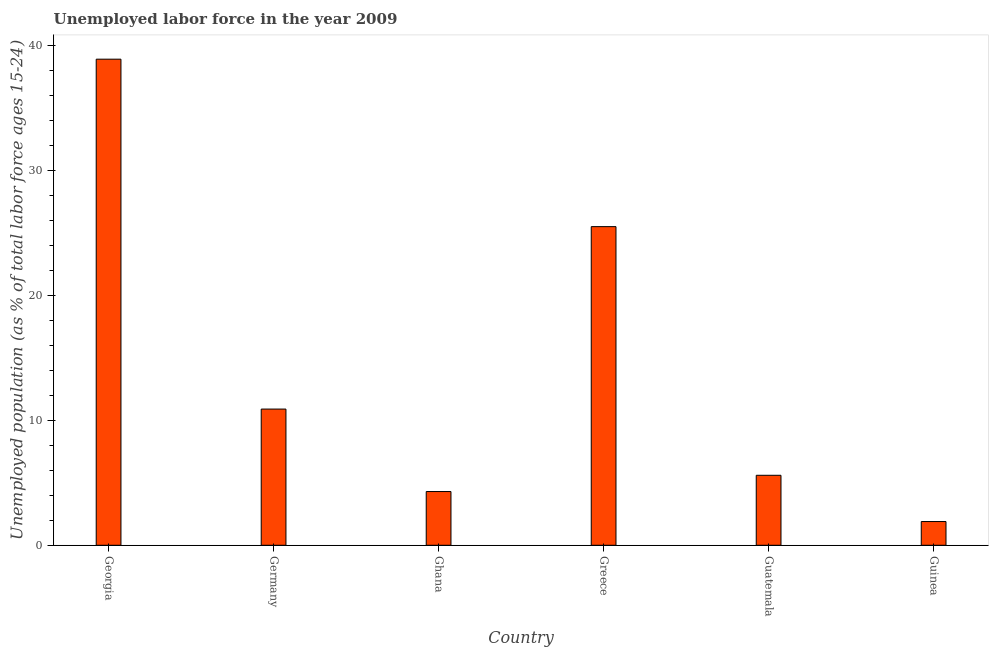Does the graph contain any zero values?
Keep it short and to the point. No. Does the graph contain grids?
Provide a succinct answer. No. What is the title of the graph?
Offer a terse response. Unemployed labor force in the year 2009. What is the label or title of the X-axis?
Offer a very short reply. Country. What is the label or title of the Y-axis?
Offer a terse response. Unemployed population (as % of total labor force ages 15-24). What is the total unemployed youth population in Guinea?
Your answer should be compact. 1.9. Across all countries, what is the maximum total unemployed youth population?
Offer a terse response. 38.9. Across all countries, what is the minimum total unemployed youth population?
Offer a very short reply. 1.9. In which country was the total unemployed youth population maximum?
Keep it short and to the point. Georgia. In which country was the total unemployed youth population minimum?
Make the answer very short. Guinea. What is the sum of the total unemployed youth population?
Make the answer very short. 87.1. What is the average total unemployed youth population per country?
Give a very brief answer. 14.52. What is the median total unemployed youth population?
Provide a short and direct response. 8.25. What is the ratio of the total unemployed youth population in Guatemala to that in Guinea?
Keep it short and to the point. 2.95. Is the total unemployed youth population in Greece less than that in Guinea?
Provide a succinct answer. No. What is the difference between the highest and the second highest total unemployed youth population?
Give a very brief answer. 13.4. Is the sum of the total unemployed youth population in Georgia and Guinea greater than the maximum total unemployed youth population across all countries?
Your answer should be very brief. Yes. Are all the bars in the graph horizontal?
Ensure brevity in your answer.  No. How many countries are there in the graph?
Provide a short and direct response. 6. What is the difference between two consecutive major ticks on the Y-axis?
Keep it short and to the point. 10. What is the Unemployed population (as % of total labor force ages 15-24) in Georgia?
Your answer should be very brief. 38.9. What is the Unemployed population (as % of total labor force ages 15-24) of Germany?
Your answer should be very brief. 10.9. What is the Unemployed population (as % of total labor force ages 15-24) in Ghana?
Keep it short and to the point. 4.3. What is the Unemployed population (as % of total labor force ages 15-24) in Greece?
Your answer should be very brief. 25.5. What is the Unemployed population (as % of total labor force ages 15-24) in Guatemala?
Your answer should be very brief. 5.6. What is the Unemployed population (as % of total labor force ages 15-24) in Guinea?
Ensure brevity in your answer.  1.9. What is the difference between the Unemployed population (as % of total labor force ages 15-24) in Georgia and Ghana?
Offer a very short reply. 34.6. What is the difference between the Unemployed population (as % of total labor force ages 15-24) in Georgia and Greece?
Your answer should be compact. 13.4. What is the difference between the Unemployed population (as % of total labor force ages 15-24) in Georgia and Guatemala?
Give a very brief answer. 33.3. What is the difference between the Unemployed population (as % of total labor force ages 15-24) in Georgia and Guinea?
Provide a succinct answer. 37. What is the difference between the Unemployed population (as % of total labor force ages 15-24) in Germany and Ghana?
Provide a short and direct response. 6.6. What is the difference between the Unemployed population (as % of total labor force ages 15-24) in Germany and Greece?
Your answer should be compact. -14.6. What is the difference between the Unemployed population (as % of total labor force ages 15-24) in Germany and Guatemala?
Offer a terse response. 5.3. What is the difference between the Unemployed population (as % of total labor force ages 15-24) in Germany and Guinea?
Offer a terse response. 9. What is the difference between the Unemployed population (as % of total labor force ages 15-24) in Ghana and Greece?
Give a very brief answer. -21.2. What is the difference between the Unemployed population (as % of total labor force ages 15-24) in Ghana and Guatemala?
Offer a terse response. -1.3. What is the difference between the Unemployed population (as % of total labor force ages 15-24) in Greece and Guinea?
Offer a very short reply. 23.6. What is the difference between the Unemployed population (as % of total labor force ages 15-24) in Guatemala and Guinea?
Your response must be concise. 3.7. What is the ratio of the Unemployed population (as % of total labor force ages 15-24) in Georgia to that in Germany?
Provide a succinct answer. 3.57. What is the ratio of the Unemployed population (as % of total labor force ages 15-24) in Georgia to that in Ghana?
Your answer should be compact. 9.05. What is the ratio of the Unemployed population (as % of total labor force ages 15-24) in Georgia to that in Greece?
Offer a very short reply. 1.52. What is the ratio of the Unemployed population (as % of total labor force ages 15-24) in Georgia to that in Guatemala?
Keep it short and to the point. 6.95. What is the ratio of the Unemployed population (as % of total labor force ages 15-24) in Georgia to that in Guinea?
Make the answer very short. 20.47. What is the ratio of the Unemployed population (as % of total labor force ages 15-24) in Germany to that in Ghana?
Your answer should be very brief. 2.54. What is the ratio of the Unemployed population (as % of total labor force ages 15-24) in Germany to that in Greece?
Your answer should be very brief. 0.43. What is the ratio of the Unemployed population (as % of total labor force ages 15-24) in Germany to that in Guatemala?
Make the answer very short. 1.95. What is the ratio of the Unemployed population (as % of total labor force ages 15-24) in Germany to that in Guinea?
Make the answer very short. 5.74. What is the ratio of the Unemployed population (as % of total labor force ages 15-24) in Ghana to that in Greece?
Offer a terse response. 0.17. What is the ratio of the Unemployed population (as % of total labor force ages 15-24) in Ghana to that in Guatemala?
Keep it short and to the point. 0.77. What is the ratio of the Unemployed population (as % of total labor force ages 15-24) in Ghana to that in Guinea?
Make the answer very short. 2.26. What is the ratio of the Unemployed population (as % of total labor force ages 15-24) in Greece to that in Guatemala?
Keep it short and to the point. 4.55. What is the ratio of the Unemployed population (as % of total labor force ages 15-24) in Greece to that in Guinea?
Offer a very short reply. 13.42. What is the ratio of the Unemployed population (as % of total labor force ages 15-24) in Guatemala to that in Guinea?
Give a very brief answer. 2.95. 